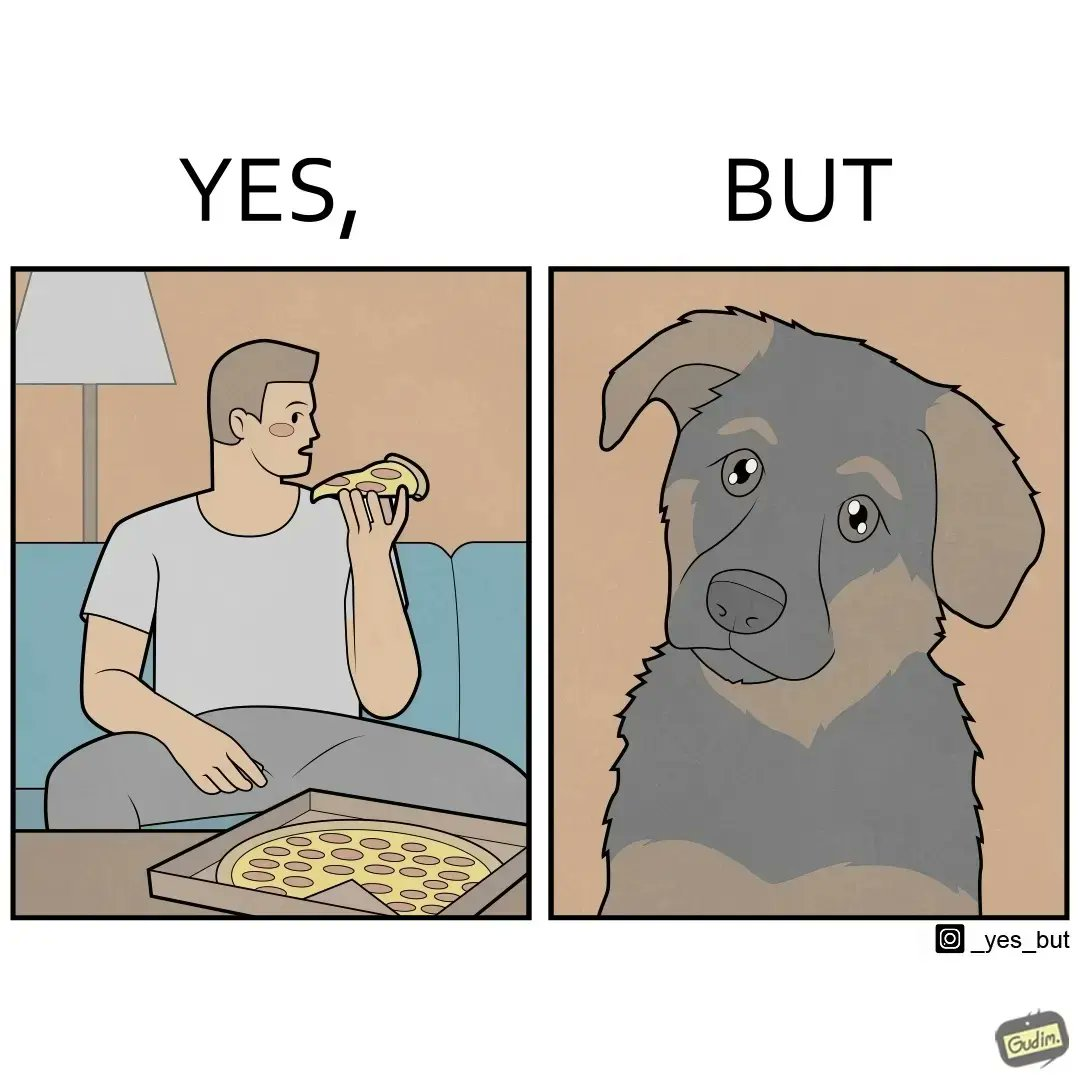Describe what you see in the left and right parts of this image. In the left part of the image: It is a man eating a pizza In the right part of the image: It is a pet dog with teary eyes 